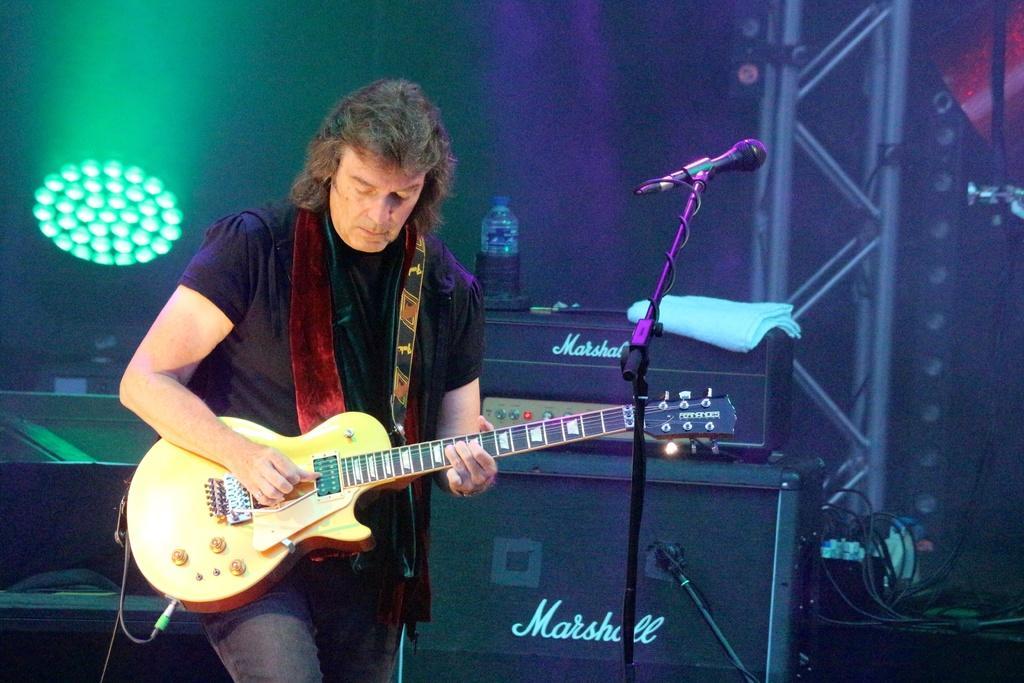Could you give a brief overview of what you see in this image? In this image I can see a man wearing black color t-shirt, jeans, standing and playing the guitar by looking at the downwards. In front of this man there is a mike stand. In the background there is a table on which a musical instrument, bottle, a white color cloth and some more objects are placed. On the right side, I can see a metal stand, some wires and on the left side there are some lights. 